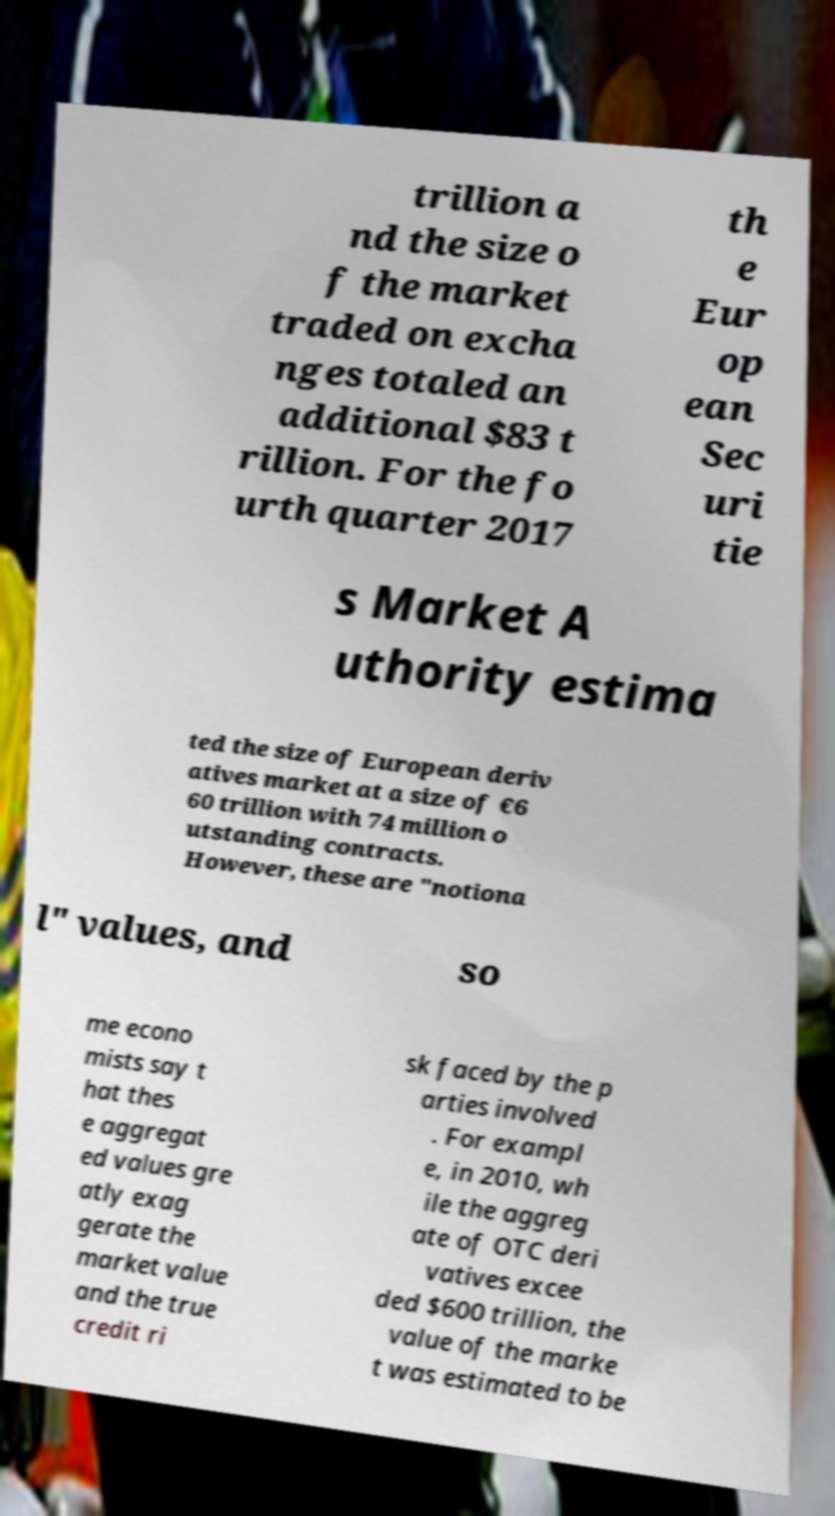Can you read and provide the text displayed in the image?This photo seems to have some interesting text. Can you extract and type it out for me? trillion a nd the size o f the market traded on excha nges totaled an additional $83 t rillion. For the fo urth quarter 2017 th e Eur op ean Sec uri tie s Market A uthority estima ted the size of European deriv atives market at a size of €6 60 trillion with 74 million o utstanding contracts. However, these are "notiona l" values, and so me econo mists say t hat thes e aggregat ed values gre atly exag gerate the market value and the true credit ri sk faced by the p arties involved . For exampl e, in 2010, wh ile the aggreg ate of OTC deri vatives excee ded $600 trillion, the value of the marke t was estimated to be 